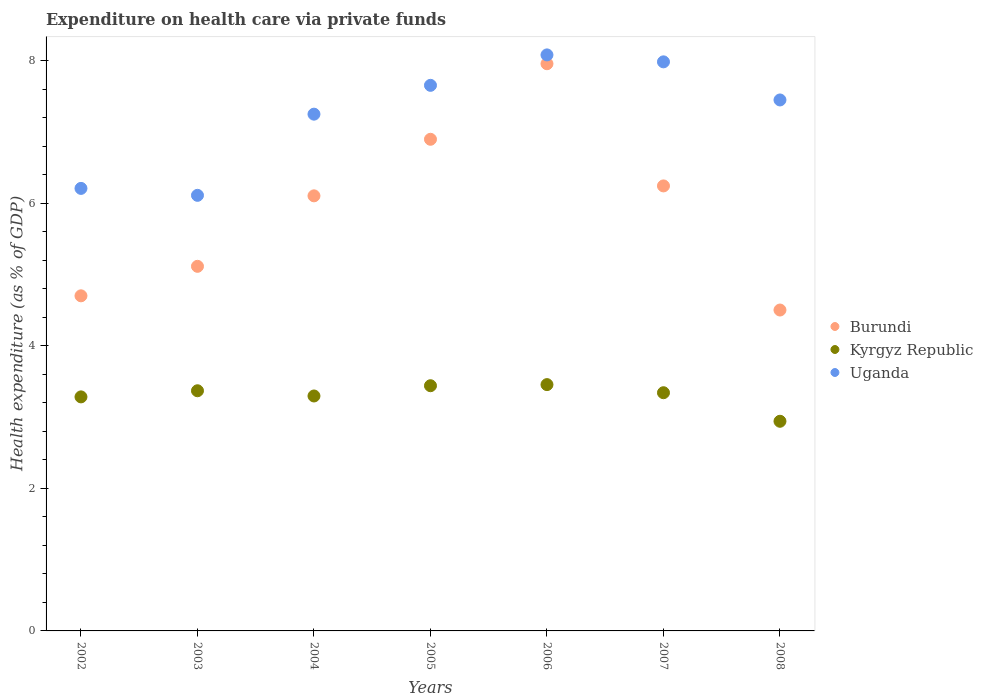Is the number of dotlines equal to the number of legend labels?
Offer a very short reply. Yes. What is the expenditure made on health care in Kyrgyz Republic in 2004?
Offer a very short reply. 3.3. Across all years, what is the maximum expenditure made on health care in Burundi?
Provide a short and direct response. 7.96. Across all years, what is the minimum expenditure made on health care in Uganda?
Your response must be concise. 6.11. In which year was the expenditure made on health care in Burundi maximum?
Your response must be concise. 2006. In which year was the expenditure made on health care in Uganda minimum?
Give a very brief answer. 2003. What is the total expenditure made on health care in Kyrgyz Republic in the graph?
Give a very brief answer. 23.14. What is the difference between the expenditure made on health care in Burundi in 2004 and that in 2006?
Your response must be concise. -1.85. What is the difference between the expenditure made on health care in Kyrgyz Republic in 2002 and the expenditure made on health care in Uganda in 2008?
Your response must be concise. -4.17. What is the average expenditure made on health care in Kyrgyz Republic per year?
Ensure brevity in your answer.  3.31. In the year 2004, what is the difference between the expenditure made on health care in Kyrgyz Republic and expenditure made on health care in Uganda?
Make the answer very short. -3.96. What is the ratio of the expenditure made on health care in Burundi in 2003 to that in 2005?
Make the answer very short. 0.74. Is the difference between the expenditure made on health care in Kyrgyz Republic in 2005 and 2008 greater than the difference between the expenditure made on health care in Uganda in 2005 and 2008?
Your answer should be compact. Yes. What is the difference between the highest and the second highest expenditure made on health care in Uganda?
Offer a terse response. 0.1. What is the difference between the highest and the lowest expenditure made on health care in Burundi?
Give a very brief answer. 3.46. In how many years, is the expenditure made on health care in Burundi greater than the average expenditure made on health care in Burundi taken over all years?
Offer a terse response. 4. Is the sum of the expenditure made on health care in Uganda in 2002 and 2005 greater than the maximum expenditure made on health care in Burundi across all years?
Offer a very short reply. Yes. Is the expenditure made on health care in Uganda strictly greater than the expenditure made on health care in Burundi over the years?
Keep it short and to the point. Yes. How many dotlines are there?
Offer a very short reply. 3. What is the difference between two consecutive major ticks on the Y-axis?
Your answer should be compact. 2. Does the graph contain any zero values?
Provide a short and direct response. No. Where does the legend appear in the graph?
Make the answer very short. Center right. How many legend labels are there?
Ensure brevity in your answer.  3. What is the title of the graph?
Your response must be concise. Expenditure on health care via private funds. Does "Italy" appear as one of the legend labels in the graph?
Provide a succinct answer. No. What is the label or title of the X-axis?
Offer a very short reply. Years. What is the label or title of the Y-axis?
Make the answer very short. Health expenditure (as % of GDP). What is the Health expenditure (as % of GDP) in Burundi in 2002?
Offer a very short reply. 4.7. What is the Health expenditure (as % of GDP) in Kyrgyz Republic in 2002?
Your answer should be very brief. 3.28. What is the Health expenditure (as % of GDP) in Uganda in 2002?
Offer a very short reply. 6.21. What is the Health expenditure (as % of GDP) in Burundi in 2003?
Your answer should be very brief. 5.12. What is the Health expenditure (as % of GDP) in Kyrgyz Republic in 2003?
Provide a succinct answer. 3.37. What is the Health expenditure (as % of GDP) in Uganda in 2003?
Offer a very short reply. 6.11. What is the Health expenditure (as % of GDP) of Burundi in 2004?
Offer a very short reply. 6.11. What is the Health expenditure (as % of GDP) in Kyrgyz Republic in 2004?
Make the answer very short. 3.3. What is the Health expenditure (as % of GDP) in Uganda in 2004?
Make the answer very short. 7.25. What is the Health expenditure (as % of GDP) of Burundi in 2005?
Offer a terse response. 6.9. What is the Health expenditure (as % of GDP) of Kyrgyz Republic in 2005?
Ensure brevity in your answer.  3.44. What is the Health expenditure (as % of GDP) in Uganda in 2005?
Make the answer very short. 7.66. What is the Health expenditure (as % of GDP) of Burundi in 2006?
Give a very brief answer. 7.96. What is the Health expenditure (as % of GDP) of Kyrgyz Republic in 2006?
Your answer should be compact. 3.46. What is the Health expenditure (as % of GDP) of Uganda in 2006?
Your answer should be compact. 8.09. What is the Health expenditure (as % of GDP) of Burundi in 2007?
Provide a succinct answer. 6.25. What is the Health expenditure (as % of GDP) of Kyrgyz Republic in 2007?
Provide a succinct answer. 3.34. What is the Health expenditure (as % of GDP) in Uganda in 2007?
Keep it short and to the point. 7.99. What is the Health expenditure (as % of GDP) of Burundi in 2008?
Your response must be concise. 4.5. What is the Health expenditure (as % of GDP) in Kyrgyz Republic in 2008?
Keep it short and to the point. 2.94. What is the Health expenditure (as % of GDP) of Uganda in 2008?
Your response must be concise. 7.45. Across all years, what is the maximum Health expenditure (as % of GDP) of Burundi?
Your answer should be compact. 7.96. Across all years, what is the maximum Health expenditure (as % of GDP) of Kyrgyz Republic?
Your answer should be very brief. 3.46. Across all years, what is the maximum Health expenditure (as % of GDP) in Uganda?
Offer a very short reply. 8.09. Across all years, what is the minimum Health expenditure (as % of GDP) in Burundi?
Provide a succinct answer. 4.5. Across all years, what is the minimum Health expenditure (as % of GDP) in Kyrgyz Republic?
Your response must be concise. 2.94. Across all years, what is the minimum Health expenditure (as % of GDP) in Uganda?
Provide a succinct answer. 6.11. What is the total Health expenditure (as % of GDP) in Burundi in the graph?
Offer a very short reply. 41.54. What is the total Health expenditure (as % of GDP) of Kyrgyz Republic in the graph?
Offer a terse response. 23.14. What is the total Health expenditure (as % of GDP) of Uganda in the graph?
Give a very brief answer. 50.76. What is the difference between the Health expenditure (as % of GDP) in Burundi in 2002 and that in 2003?
Your response must be concise. -0.41. What is the difference between the Health expenditure (as % of GDP) in Kyrgyz Republic in 2002 and that in 2003?
Offer a very short reply. -0.09. What is the difference between the Health expenditure (as % of GDP) in Uganda in 2002 and that in 2003?
Offer a very short reply. 0.1. What is the difference between the Health expenditure (as % of GDP) of Burundi in 2002 and that in 2004?
Make the answer very short. -1.4. What is the difference between the Health expenditure (as % of GDP) in Kyrgyz Republic in 2002 and that in 2004?
Make the answer very short. -0.01. What is the difference between the Health expenditure (as % of GDP) in Uganda in 2002 and that in 2004?
Ensure brevity in your answer.  -1.04. What is the difference between the Health expenditure (as % of GDP) in Burundi in 2002 and that in 2005?
Provide a succinct answer. -2.2. What is the difference between the Health expenditure (as % of GDP) of Kyrgyz Republic in 2002 and that in 2005?
Your answer should be very brief. -0.16. What is the difference between the Health expenditure (as % of GDP) in Uganda in 2002 and that in 2005?
Provide a succinct answer. -1.45. What is the difference between the Health expenditure (as % of GDP) of Burundi in 2002 and that in 2006?
Keep it short and to the point. -3.26. What is the difference between the Health expenditure (as % of GDP) of Kyrgyz Republic in 2002 and that in 2006?
Your answer should be compact. -0.17. What is the difference between the Health expenditure (as % of GDP) in Uganda in 2002 and that in 2006?
Your answer should be very brief. -1.87. What is the difference between the Health expenditure (as % of GDP) of Burundi in 2002 and that in 2007?
Offer a very short reply. -1.54. What is the difference between the Health expenditure (as % of GDP) in Kyrgyz Republic in 2002 and that in 2007?
Offer a very short reply. -0.06. What is the difference between the Health expenditure (as % of GDP) in Uganda in 2002 and that in 2007?
Provide a succinct answer. -1.78. What is the difference between the Health expenditure (as % of GDP) in Burundi in 2002 and that in 2008?
Provide a succinct answer. 0.2. What is the difference between the Health expenditure (as % of GDP) in Kyrgyz Republic in 2002 and that in 2008?
Provide a succinct answer. 0.34. What is the difference between the Health expenditure (as % of GDP) in Uganda in 2002 and that in 2008?
Make the answer very short. -1.24. What is the difference between the Health expenditure (as % of GDP) in Burundi in 2003 and that in 2004?
Offer a terse response. -0.99. What is the difference between the Health expenditure (as % of GDP) in Kyrgyz Republic in 2003 and that in 2004?
Give a very brief answer. 0.07. What is the difference between the Health expenditure (as % of GDP) of Uganda in 2003 and that in 2004?
Ensure brevity in your answer.  -1.14. What is the difference between the Health expenditure (as % of GDP) of Burundi in 2003 and that in 2005?
Keep it short and to the point. -1.78. What is the difference between the Health expenditure (as % of GDP) in Kyrgyz Republic in 2003 and that in 2005?
Your answer should be compact. -0.07. What is the difference between the Health expenditure (as % of GDP) in Uganda in 2003 and that in 2005?
Provide a short and direct response. -1.54. What is the difference between the Health expenditure (as % of GDP) of Burundi in 2003 and that in 2006?
Keep it short and to the point. -2.84. What is the difference between the Health expenditure (as % of GDP) of Kyrgyz Republic in 2003 and that in 2006?
Ensure brevity in your answer.  -0.09. What is the difference between the Health expenditure (as % of GDP) of Uganda in 2003 and that in 2006?
Your answer should be compact. -1.97. What is the difference between the Health expenditure (as % of GDP) of Burundi in 2003 and that in 2007?
Offer a terse response. -1.13. What is the difference between the Health expenditure (as % of GDP) in Kyrgyz Republic in 2003 and that in 2007?
Provide a succinct answer. 0.03. What is the difference between the Health expenditure (as % of GDP) of Uganda in 2003 and that in 2007?
Ensure brevity in your answer.  -1.87. What is the difference between the Health expenditure (as % of GDP) of Burundi in 2003 and that in 2008?
Give a very brief answer. 0.61. What is the difference between the Health expenditure (as % of GDP) in Kyrgyz Republic in 2003 and that in 2008?
Provide a short and direct response. 0.43. What is the difference between the Health expenditure (as % of GDP) in Uganda in 2003 and that in 2008?
Keep it short and to the point. -1.34. What is the difference between the Health expenditure (as % of GDP) in Burundi in 2004 and that in 2005?
Ensure brevity in your answer.  -0.79. What is the difference between the Health expenditure (as % of GDP) of Kyrgyz Republic in 2004 and that in 2005?
Offer a terse response. -0.14. What is the difference between the Health expenditure (as % of GDP) of Uganda in 2004 and that in 2005?
Your answer should be very brief. -0.4. What is the difference between the Health expenditure (as % of GDP) in Burundi in 2004 and that in 2006?
Your answer should be very brief. -1.85. What is the difference between the Health expenditure (as % of GDP) in Kyrgyz Republic in 2004 and that in 2006?
Make the answer very short. -0.16. What is the difference between the Health expenditure (as % of GDP) of Uganda in 2004 and that in 2006?
Your answer should be very brief. -0.83. What is the difference between the Health expenditure (as % of GDP) in Burundi in 2004 and that in 2007?
Keep it short and to the point. -0.14. What is the difference between the Health expenditure (as % of GDP) of Kyrgyz Republic in 2004 and that in 2007?
Provide a short and direct response. -0.05. What is the difference between the Health expenditure (as % of GDP) in Uganda in 2004 and that in 2007?
Ensure brevity in your answer.  -0.73. What is the difference between the Health expenditure (as % of GDP) in Burundi in 2004 and that in 2008?
Provide a short and direct response. 1.6. What is the difference between the Health expenditure (as % of GDP) of Kyrgyz Republic in 2004 and that in 2008?
Make the answer very short. 0.35. What is the difference between the Health expenditure (as % of GDP) in Uganda in 2004 and that in 2008?
Provide a short and direct response. -0.2. What is the difference between the Health expenditure (as % of GDP) in Burundi in 2005 and that in 2006?
Offer a terse response. -1.06. What is the difference between the Health expenditure (as % of GDP) in Kyrgyz Republic in 2005 and that in 2006?
Your answer should be compact. -0.02. What is the difference between the Health expenditure (as % of GDP) in Uganda in 2005 and that in 2006?
Make the answer very short. -0.43. What is the difference between the Health expenditure (as % of GDP) in Burundi in 2005 and that in 2007?
Provide a succinct answer. 0.65. What is the difference between the Health expenditure (as % of GDP) of Kyrgyz Republic in 2005 and that in 2007?
Offer a terse response. 0.1. What is the difference between the Health expenditure (as % of GDP) in Uganda in 2005 and that in 2007?
Give a very brief answer. -0.33. What is the difference between the Health expenditure (as % of GDP) in Burundi in 2005 and that in 2008?
Provide a short and direct response. 2.4. What is the difference between the Health expenditure (as % of GDP) of Kyrgyz Republic in 2005 and that in 2008?
Your answer should be compact. 0.5. What is the difference between the Health expenditure (as % of GDP) of Uganda in 2005 and that in 2008?
Ensure brevity in your answer.  0.21. What is the difference between the Health expenditure (as % of GDP) of Burundi in 2006 and that in 2007?
Make the answer very short. 1.72. What is the difference between the Health expenditure (as % of GDP) in Kyrgyz Republic in 2006 and that in 2007?
Offer a very short reply. 0.11. What is the difference between the Health expenditure (as % of GDP) in Uganda in 2006 and that in 2007?
Your answer should be very brief. 0.1. What is the difference between the Health expenditure (as % of GDP) of Burundi in 2006 and that in 2008?
Provide a succinct answer. 3.46. What is the difference between the Health expenditure (as % of GDP) in Kyrgyz Republic in 2006 and that in 2008?
Provide a short and direct response. 0.51. What is the difference between the Health expenditure (as % of GDP) of Uganda in 2006 and that in 2008?
Ensure brevity in your answer.  0.63. What is the difference between the Health expenditure (as % of GDP) of Burundi in 2007 and that in 2008?
Offer a very short reply. 1.74. What is the difference between the Health expenditure (as % of GDP) in Kyrgyz Republic in 2007 and that in 2008?
Ensure brevity in your answer.  0.4. What is the difference between the Health expenditure (as % of GDP) in Uganda in 2007 and that in 2008?
Provide a short and direct response. 0.53. What is the difference between the Health expenditure (as % of GDP) in Burundi in 2002 and the Health expenditure (as % of GDP) in Kyrgyz Republic in 2003?
Your response must be concise. 1.33. What is the difference between the Health expenditure (as % of GDP) of Burundi in 2002 and the Health expenditure (as % of GDP) of Uganda in 2003?
Provide a succinct answer. -1.41. What is the difference between the Health expenditure (as % of GDP) of Kyrgyz Republic in 2002 and the Health expenditure (as % of GDP) of Uganda in 2003?
Give a very brief answer. -2.83. What is the difference between the Health expenditure (as % of GDP) of Burundi in 2002 and the Health expenditure (as % of GDP) of Kyrgyz Republic in 2004?
Ensure brevity in your answer.  1.41. What is the difference between the Health expenditure (as % of GDP) in Burundi in 2002 and the Health expenditure (as % of GDP) in Uganda in 2004?
Provide a succinct answer. -2.55. What is the difference between the Health expenditure (as % of GDP) of Kyrgyz Republic in 2002 and the Health expenditure (as % of GDP) of Uganda in 2004?
Provide a short and direct response. -3.97. What is the difference between the Health expenditure (as % of GDP) of Burundi in 2002 and the Health expenditure (as % of GDP) of Kyrgyz Republic in 2005?
Your answer should be very brief. 1.26. What is the difference between the Health expenditure (as % of GDP) in Burundi in 2002 and the Health expenditure (as % of GDP) in Uganda in 2005?
Keep it short and to the point. -2.95. What is the difference between the Health expenditure (as % of GDP) in Kyrgyz Republic in 2002 and the Health expenditure (as % of GDP) in Uganda in 2005?
Your answer should be very brief. -4.37. What is the difference between the Health expenditure (as % of GDP) of Burundi in 2002 and the Health expenditure (as % of GDP) of Kyrgyz Republic in 2006?
Your answer should be very brief. 1.25. What is the difference between the Health expenditure (as % of GDP) in Burundi in 2002 and the Health expenditure (as % of GDP) in Uganda in 2006?
Ensure brevity in your answer.  -3.38. What is the difference between the Health expenditure (as % of GDP) of Kyrgyz Republic in 2002 and the Health expenditure (as % of GDP) of Uganda in 2006?
Keep it short and to the point. -4.8. What is the difference between the Health expenditure (as % of GDP) of Burundi in 2002 and the Health expenditure (as % of GDP) of Kyrgyz Republic in 2007?
Your response must be concise. 1.36. What is the difference between the Health expenditure (as % of GDP) of Burundi in 2002 and the Health expenditure (as % of GDP) of Uganda in 2007?
Offer a very short reply. -3.28. What is the difference between the Health expenditure (as % of GDP) in Kyrgyz Republic in 2002 and the Health expenditure (as % of GDP) in Uganda in 2007?
Keep it short and to the point. -4.7. What is the difference between the Health expenditure (as % of GDP) in Burundi in 2002 and the Health expenditure (as % of GDP) in Kyrgyz Republic in 2008?
Your response must be concise. 1.76. What is the difference between the Health expenditure (as % of GDP) in Burundi in 2002 and the Health expenditure (as % of GDP) in Uganda in 2008?
Your answer should be very brief. -2.75. What is the difference between the Health expenditure (as % of GDP) of Kyrgyz Republic in 2002 and the Health expenditure (as % of GDP) of Uganda in 2008?
Offer a very short reply. -4.17. What is the difference between the Health expenditure (as % of GDP) of Burundi in 2003 and the Health expenditure (as % of GDP) of Kyrgyz Republic in 2004?
Your answer should be very brief. 1.82. What is the difference between the Health expenditure (as % of GDP) in Burundi in 2003 and the Health expenditure (as % of GDP) in Uganda in 2004?
Make the answer very short. -2.14. What is the difference between the Health expenditure (as % of GDP) in Kyrgyz Republic in 2003 and the Health expenditure (as % of GDP) in Uganda in 2004?
Offer a terse response. -3.88. What is the difference between the Health expenditure (as % of GDP) in Burundi in 2003 and the Health expenditure (as % of GDP) in Kyrgyz Republic in 2005?
Offer a very short reply. 1.68. What is the difference between the Health expenditure (as % of GDP) in Burundi in 2003 and the Health expenditure (as % of GDP) in Uganda in 2005?
Give a very brief answer. -2.54. What is the difference between the Health expenditure (as % of GDP) in Kyrgyz Republic in 2003 and the Health expenditure (as % of GDP) in Uganda in 2005?
Provide a short and direct response. -4.29. What is the difference between the Health expenditure (as % of GDP) in Burundi in 2003 and the Health expenditure (as % of GDP) in Kyrgyz Republic in 2006?
Give a very brief answer. 1.66. What is the difference between the Health expenditure (as % of GDP) in Burundi in 2003 and the Health expenditure (as % of GDP) in Uganda in 2006?
Offer a terse response. -2.97. What is the difference between the Health expenditure (as % of GDP) of Kyrgyz Republic in 2003 and the Health expenditure (as % of GDP) of Uganda in 2006?
Offer a very short reply. -4.71. What is the difference between the Health expenditure (as % of GDP) in Burundi in 2003 and the Health expenditure (as % of GDP) in Kyrgyz Republic in 2007?
Make the answer very short. 1.77. What is the difference between the Health expenditure (as % of GDP) in Burundi in 2003 and the Health expenditure (as % of GDP) in Uganda in 2007?
Keep it short and to the point. -2.87. What is the difference between the Health expenditure (as % of GDP) of Kyrgyz Republic in 2003 and the Health expenditure (as % of GDP) of Uganda in 2007?
Offer a very short reply. -4.62. What is the difference between the Health expenditure (as % of GDP) of Burundi in 2003 and the Health expenditure (as % of GDP) of Kyrgyz Republic in 2008?
Offer a very short reply. 2.17. What is the difference between the Health expenditure (as % of GDP) of Burundi in 2003 and the Health expenditure (as % of GDP) of Uganda in 2008?
Ensure brevity in your answer.  -2.34. What is the difference between the Health expenditure (as % of GDP) in Kyrgyz Republic in 2003 and the Health expenditure (as % of GDP) in Uganda in 2008?
Your response must be concise. -4.08. What is the difference between the Health expenditure (as % of GDP) in Burundi in 2004 and the Health expenditure (as % of GDP) in Kyrgyz Republic in 2005?
Make the answer very short. 2.67. What is the difference between the Health expenditure (as % of GDP) in Burundi in 2004 and the Health expenditure (as % of GDP) in Uganda in 2005?
Provide a succinct answer. -1.55. What is the difference between the Health expenditure (as % of GDP) of Kyrgyz Republic in 2004 and the Health expenditure (as % of GDP) of Uganda in 2005?
Your answer should be compact. -4.36. What is the difference between the Health expenditure (as % of GDP) in Burundi in 2004 and the Health expenditure (as % of GDP) in Kyrgyz Republic in 2006?
Offer a very short reply. 2.65. What is the difference between the Health expenditure (as % of GDP) in Burundi in 2004 and the Health expenditure (as % of GDP) in Uganda in 2006?
Give a very brief answer. -1.98. What is the difference between the Health expenditure (as % of GDP) in Kyrgyz Republic in 2004 and the Health expenditure (as % of GDP) in Uganda in 2006?
Your response must be concise. -4.79. What is the difference between the Health expenditure (as % of GDP) in Burundi in 2004 and the Health expenditure (as % of GDP) in Kyrgyz Republic in 2007?
Offer a very short reply. 2.76. What is the difference between the Health expenditure (as % of GDP) in Burundi in 2004 and the Health expenditure (as % of GDP) in Uganda in 2007?
Provide a short and direct response. -1.88. What is the difference between the Health expenditure (as % of GDP) of Kyrgyz Republic in 2004 and the Health expenditure (as % of GDP) of Uganda in 2007?
Offer a very short reply. -4.69. What is the difference between the Health expenditure (as % of GDP) of Burundi in 2004 and the Health expenditure (as % of GDP) of Kyrgyz Republic in 2008?
Your answer should be very brief. 3.16. What is the difference between the Health expenditure (as % of GDP) in Burundi in 2004 and the Health expenditure (as % of GDP) in Uganda in 2008?
Ensure brevity in your answer.  -1.35. What is the difference between the Health expenditure (as % of GDP) of Kyrgyz Republic in 2004 and the Health expenditure (as % of GDP) of Uganda in 2008?
Give a very brief answer. -4.16. What is the difference between the Health expenditure (as % of GDP) of Burundi in 2005 and the Health expenditure (as % of GDP) of Kyrgyz Republic in 2006?
Provide a succinct answer. 3.44. What is the difference between the Health expenditure (as % of GDP) of Burundi in 2005 and the Health expenditure (as % of GDP) of Uganda in 2006?
Offer a terse response. -1.18. What is the difference between the Health expenditure (as % of GDP) in Kyrgyz Republic in 2005 and the Health expenditure (as % of GDP) in Uganda in 2006?
Make the answer very short. -4.64. What is the difference between the Health expenditure (as % of GDP) in Burundi in 2005 and the Health expenditure (as % of GDP) in Kyrgyz Republic in 2007?
Give a very brief answer. 3.56. What is the difference between the Health expenditure (as % of GDP) in Burundi in 2005 and the Health expenditure (as % of GDP) in Uganda in 2007?
Your answer should be compact. -1.09. What is the difference between the Health expenditure (as % of GDP) in Kyrgyz Republic in 2005 and the Health expenditure (as % of GDP) in Uganda in 2007?
Provide a succinct answer. -4.55. What is the difference between the Health expenditure (as % of GDP) of Burundi in 2005 and the Health expenditure (as % of GDP) of Kyrgyz Republic in 2008?
Your answer should be very brief. 3.96. What is the difference between the Health expenditure (as % of GDP) in Burundi in 2005 and the Health expenditure (as % of GDP) in Uganda in 2008?
Provide a succinct answer. -0.55. What is the difference between the Health expenditure (as % of GDP) in Kyrgyz Republic in 2005 and the Health expenditure (as % of GDP) in Uganda in 2008?
Your response must be concise. -4.01. What is the difference between the Health expenditure (as % of GDP) of Burundi in 2006 and the Health expenditure (as % of GDP) of Kyrgyz Republic in 2007?
Offer a very short reply. 4.62. What is the difference between the Health expenditure (as % of GDP) in Burundi in 2006 and the Health expenditure (as % of GDP) in Uganda in 2007?
Make the answer very short. -0.03. What is the difference between the Health expenditure (as % of GDP) of Kyrgyz Republic in 2006 and the Health expenditure (as % of GDP) of Uganda in 2007?
Keep it short and to the point. -4.53. What is the difference between the Health expenditure (as % of GDP) of Burundi in 2006 and the Health expenditure (as % of GDP) of Kyrgyz Republic in 2008?
Keep it short and to the point. 5.02. What is the difference between the Health expenditure (as % of GDP) of Burundi in 2006 and the Health expenditure (as % of GDP) of Uganda in 2008?
Offer a very short reply. 0.51. What is the difference between the Health expenditure (as % of GDP) in Kyrgyz Republic in 2006 and the Health expenditure (as % of GDP) in Uganda in 2008?
Offer a terse response. -4. What is the difference between the Health expenditure (as % of GDP) of Burundi in 2007 and the Health expenditure (as % of GDP) of Kyrgyz Republic in 2008?
Offer a terse response. 3.3. What is the difference between the Health expenditure (as % of GDP) in Burundi in 2007 and the Health expenditure (as % of GDP) in Uganda in 2008?
Give a very brief answer. -1.21. What is the difference between the Health expenditure (as % of GDP) in Kyrgyz Republic in 2007 and the Health expenditure (as % of GDP) in Uganda in 2008?
Keep it short and to the point. -4.11. What is the average Health expenditure (as % of GDP) of Burundi per year?
Give a very brief answer. 5.93. What is the average Health expenditure (as % of GDP) in Kyrgyz Republic per year?
Offer a terse response. 3.31. What is the average Health expenditure (as % of GDP) of Uganda per year?
Provide a succinct answer. 7.25. In the year 2002, what is the difference between the Health expenditure (as % of GDP) of Burundi and Health expenditure (as % of GDP) of Kyrgyz Republic?
Offer a terse response. 1.42. In the year 2002, what is the difference between the Health expenditure (as % of GDP) in Burundi and Health expenditure (as % of GDP) in Uganda?
Give a very brief answer. -1.51. In the year 2002, what is the difference between the Health expenditure (as % of GDP) of Kyrgyz Republic and Health expenditure (as % of GDP) of Uganda?
Provide a short and direct response. -2.93. In the year 2003, what is the difference between the Health expenditure (as % of GDP) of Burundi and Health expenditure (as % of GDP) of Kyrgyz Republic?
Offer a very short reply. 1.75. In the year 2003, what is the difference between the Health expenditure (as % of GDP) of Burundi and Health expenditure (as % of GDP) of Uganda?
Provide a succinct answer. -1. In the year 2003, what is the difference between the Health expenditure (as % of GDP) in Kyrgyz Republic and Health expenditure (as % of GDP) in Uganda?
Provide a succinct answer. -2.74. In the year 2004, what is the difference between the Health expenditure (as % of GDP) of Burundi and Health expenditure (as % of GDP) of Kyrgyz Republic?
Give a very brief answer. 2.81. In the year 2004, what is the difference between the Health expenditure (as % of GDP) in Burundi and Health expenditure (as % of GDP) in Uganda?
Your answer should be compact. -1.15. In the year 2004, what is the difference between the Health expenditure (as % of GDP) in Kyrgyz Republic and Health expenditure (as % of GDP) in Uganda?
Provide a short and direct response. -3.96. In the year 2005, what is the difference between the Health expenditure (as % of GDP) in Burundi and Health expenditure (as % of GDP) in Kyrgyz Republic?
Offer a very short reply. 3.46. In the year 2005, what is the difference between the Health expenditure (as % of GDP) in Burundi and Health expenditure (as % of GDP) in Uganda?
Your response must be concise. -0.76. In the year 2005, what is the difference between the Health expenditure (as % of GDP) in Kyrgyz Republic and Health expenditure (as % of GDP) in Uganda?
Provide a succinct answer. -4.22. In the year 2006, what is the difference between the Health expenditure (as % of GDP) of Burundi and Health expenditure (as % of GDP) of Kyrgyz Republic?
Your answer should be compact. 4.5. In the year 2006, what is the difference between the Health expenditure (as % of GDP) of Burundi and Health expenditure (as % of GDP) of Uganda?
Make the answer very short. -0.12. In the year 2006, what is the difference between the Health expenditure (as % of GDP) of Kyrgyz Republic and Health expenditure (as % of GDP) of Uganda?
Make the answer very short. -4.63. In the year 2007, what is the difference between the Health expenditure (as % of GDP) in Burundi and Health expenditure (as % of GDP) in Kyrgyz Republic?
Offer a very short reply. 2.9. In the year 2007, what is the difference between the Health expenditure (as % of GDP) in Burundi and Health expenditure (as % of GDP) in Uganda?
Make the answer very short. -1.74. In the year 2007, what is the difference between the Health expenditure (as % of GDP) in Kyrgyz Republic and Health expenditure (as % of GDP) in Uganda?
Give a very brief answer. -4.64. In the year 2008, what is the difference between the Health expenditure (as % of GDP) of Burundi and Health expenditure (as % of GDP) of Kyrgyz Republic?
Your answer should be very brief. 1.56. In the year 2008, what is the difference between the Health expenditure (as % of GDP) in Burundi and Health expenditure (as % of GDP) in Uganda?
Offer a very short reply. -2.95. In the year 2008, what is the difference between the Health expenditure (as % of GDP) of Kyrgyz Republic and Health expenditure (as % of GDP) of Uganda?
Your response must be concise. -4.51. What is the ratio of the Health expenditure (as % of GDP) of Burundi in 2002 to that in 2003?
Give a very brief answer. 0.92. What is the ratio of the Health expenditure (as % of GDP) of Kyrgyz Republic in 2002 to that in 2003?
Your answer should be very brief. 0.97. What is the ratio of the Health expenditure (as % of GDP) in Uganda in 2002 to that in 2003?
Make the answer very short. 1.02. What is the ratio of the Health expenditure (as % of GDP) in Burundi in 2002 to that in 2004?
Provide a short and direct response. 0.77. What is the ratio of the Health expenditure (as % of GDP) of Uganda in 2002 to that in 2004?
Your answer should be compact. 0.86. What is the ratio of the Health expenditure (as % of GDP) of Burundi in 2002 to that in 2005?
Your response must be concise. 0.68. What is the ratio of the Health expenditure (as % of GDP) of Kyrgyz Republic in 2002 to that in 2005?
Ensure brevity in your answer.  0.95. What is the ratio of the Health expenditure (as % of GDP) in Uganda in 2002 to that in 2005?
Offer a terse response. 0.81. What is the ratio of the Health expenditure (as % of GDP) in Burundi in 2002 to that in 2006?
Your response must be concise. 0.59. What is the ratio of the Health expenditure (as % of GDP) of Kyrgyz Republic in 2002 to that in 2006?
Provide a short and direct response. 0.95. What is the ratio of the Health expenditure (as % of GDP) in Uganda in 2002 to that in 2006?
Your response must be concise. 0.77. What is the ratio of the Health expenditure (as % of GDP) in Burundi in 2002 to that in 2007?
Give a very brief answer. 0.75. What is the ratio of the Health expenditure (as % of GDP) in Kyrgyz Republic in 2002 to that in 2007?
Give a very brief answer. 0.98. What is the ratio of the Health expenditure (as % of GDP) of Uganda in 2002 to that in 2007?
Offer a terse response. 0.78. What is the ratio of the Health expenditure (as % of GDP) of Burundi in 2002 to that in 2008?
Keep it short and to the point. 1.04. What is the ratio of the Health expenditure (as % of GDP) of Kyrgyz Republic in 2002 to that in 2008?
Your answer should be very brief. 1.12. What is the ratio of the Health expenditure (as % of GDP) in Uganda in 2002 to that in 2008?
Keep it short and to the point. 0.83. What is the ratio of the Health expenditure (as % of GDP) of Burundi in 2003 to that in 2004?
Give a very brief answer. 0.84. What is the ratio of the Health expenditure (as % of GDP) of Kyrgyz Republic in 2003 to that in 2004?
Give a very brief answer. 1.02. What is the ratio of the Health expenditure (as % of GDP) in Uganda in 2003 to that in 2004?
Ensure brevity in your answer.  0.84. What is the ratio of the Health expenditure (as % of GDP) in Burundi in 2003 to that in 2005?
Offer a very short reply. 0.74. What is the ratio of the Health expenditure (as % of GDP) in Kyrgyz Republic in 2003 to that in 2005?
Keep it short and to the point. 0.98. What is the ratio of the Health expenditure (as % of GDP) in Uganda in 2003 to that in 2005?
Your answer should be compact. 0.8. What is the ratio of the Health expenditure (as % of GDP) of Burundi in 2003 to that in 2006?
Your answer should be very brief. 0.64. What is the ratio of the Health expenditure (as % of GDP) of Kyrgyz Republic in 2003 to that in 2006?
Your response must be concise. 0.98. What is the ratio of the Health expenditure (as % of GDP) in Uganda in 2003 to that in 2006?
Ensure brevity in your answer.  0.76. What is the ratio of the Health expenditure (as % of GDP) in Burundi in 2003 to that in 2007?
Offer a terse response. 0.82. What is the ratio of the Health expenditure (as % of GDP) of Kyrgyz Republic in 2003 to that in 2007?
Keep it short and to the point. 1.01. What is the ratio of the Health expenditure (as % of GDP) of Uganda in 2003 to that in 2007?
Offer a terse response. 0.77. What is the ratio of the Health expenditure (as % of GDP) of Burundi in 2003 to that in 2008?
Give a very brief answer. 1.14. What is the ratio of the Health expenditure (as % of GDP) in Kyrgyz Republic in 2003 to that in 2008?
Provide a short and direct response. 1.15. What is the ratio of the Health expenditure (as % of GDP) in Uganda in 2003 to that in 2008?
Your answer should be very brief. 0.82. What is the ratio of the Health expenditure (as % of GDP) of Burundi in 2004 to that in 2005?
Provide a short and direct response. 0.89. What is the ratio of the Health expenditure (as % of GDP) in Kyrgyz Republic in 2004 to that in 2005?
Provide a succinct answer. 0.96. What is the ratio of the Health expenditure (as % of GDP) in Uganda in 2004 to that in 2005?
Give a very brief answer. 0.95. What is the ratio of the Health expenditure (as % of GDP) in Burundi in 2004 to that in 2006?
Your answer should be compact. 0.77. What is the ratio of the Health expenditure (as % of GDP) in Kyrgyz Republic in 2004 to that in 2006?
Ensure brevity in your answer.  0.95. What is the ratio of the Health expenditure (as % of GDP) in Uganda in 2004 to that in 2006?
Keep it short and to the point. 0.9. What is the ratio of the Health expenditure (as % of GDP) in Burundi in 2004 to that in 2007?
Ensure brevity in your answer.  0.98. What is the ratio of the Health expenditure (as % of GDP) in Kyrgyz Republic in 2004 to that in 2007?
Provide a succinct answer. 0.99. What is the ratio of the Health expenditure (as % of GDP) of Uganda in 2004 to that in 2007?
Your answer should be compact. 0.91. What is the ratio of the Health expenditure (as % of GDP) of Burundi in 2004 to that in 2008?
Give a very brief answer. 1.36. What is the ratio of the Health expenditure (as % of GDP) of Kyrgyz Republic in 2004 to that in 2008?
Keep it short and to the point. 1.12. What is the ratio of the Health expenditure (as % of GDP) in Uganda in 2004 to that in 2008?
Provide a short and direct response. 0.97. What is the ratio of the Health expenditure (as % of GDP) of Burundi in 2005 to that in 2006?
Your answer should be very brief. 0.87. What is the ratio of the Health expenditure (as % of GDP) in Kyrgyz Republic in 2005 to that in 2006?
Your answer should be very brief. 1. What is the ratio of the Health expenditure (as % of GDP) of Uganda in 2005 to that in 2006?
Ensure brevity in your answer.  0.95. What is the ratio of the Health expenditure (as % of GDP) of Burundi in 2005 to that in 2007?
Offer a very short reply. 1.1. What is the ratio of the Health expenditure (as % of GDP) of Kyrgyz Republic in 2005 to that in 2007?
Ensure brevity in your answer.  1.03. What is the ratio of the Health expenditure (as % of GDP) in Uganda in 2005 to that in 2007?
Your answer should be very brief. 0.96. What is the ratio of the Health expenditure (as % of GDP) in Burundi in 2005 to that in 2008?
Offer a terse response. 1.53. What is the ratio of the Health expenditure (as % of GDP) of Kyrgyz Republic in 2005 to that in 2008?
Your answer should be compact. 1.17. What is the ratio of the Health expenditure (as % of GDP) of Uganda in 2005 to that in 2008?
Your answer should be very brief. 1.03. What is the ratio of the Health expenditure (as % of GDP) of Burundi in 2006 to that in 2007?
Provide a succinct answer. 1.27. What is the ratio of the Health expenditure (as % of GDP) of Kyrgyz Republic in 2006 to that in 2007?
Your answer should be very brief. 1.03. What is the ratio of the Health expenditure (as % of GDP) of Uganda in 2006 to that in 2007?
Keep it short and to the point. 1.01. What is the ratio of the Health expenditure (as % of GDP) in Burundi in 2006 to that in 2008?
Your answer should be very brief. 1.77. What is the ratio of the Health expenditure (as % of GDP) in Kyrgyz Republic in 2006 to that in 2008?
Your response must be concise. 1.17. What is the ratio of the Health expenditure (as % of GDP) in Uganda in 2006 to that in 2008?
Your answer should be compact. 1.08. What is the ratio of the Health expenditure (as % of GDP) of Burundi in 2007 to that in 2008?
Ensure brevity in your answer.  1.39. What is the ratio of the Health expenditure (as % of GDP) in Kyrgyz Republic in 2007 to that in 2008?
Give a very brief answer. 1.14. What is the ratio of the Health expenditure (as % of GDP) of Uganda in 2007 to that in 2008?
Offer a terse response. 1.07. What is the difference between the highest and the second highest Health expenditure (as % of GDP) of Burundi?
Your response must be concise. 1.06. What is the difference between the highest and the second highest Health expenditure (as % of GDP) of Kyrgyz Republic?
Your answer should be very brief. 0.02. What is the difference between the highest and the second highest Health expenditure (as % of GDP) of Uganda?
Your response must be concise. 0.1. What is the difference between the highest and the lowest Health expenditure (as % of GDP) of Burundi?
Provide a succinct answer. 3.46. What is the difference between the highest and the lowest Health expenditure (as % of GDP) of Kyrgyz Republic?
Your answer should be compact. 0.51. What is the difference between the highest and the lowest Health expenditure (as % of GDP) of Uganda?
Provide a short and direct response. 1.97. 